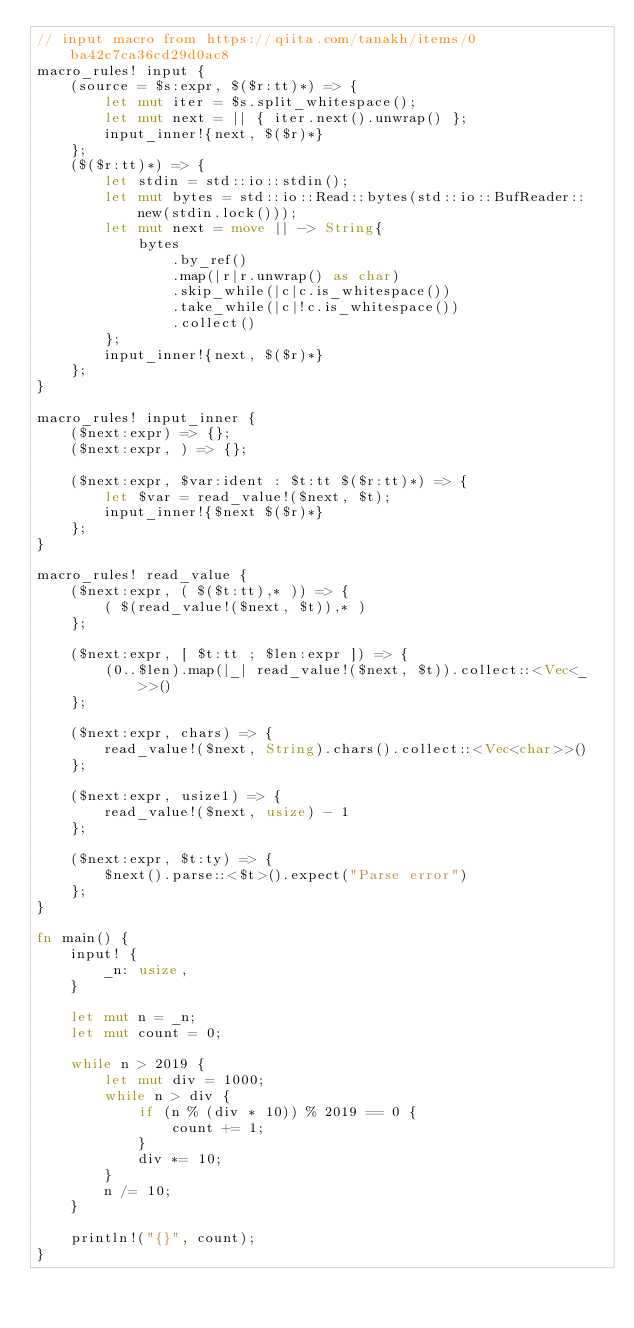Convert code to text. <code><loc_0><loc_0><loc_500><loc_500><_Rust_>// input macro from https://qiita.com/tanakh/items/0ba42c7ca36cd29d0ac8
macro_rules! input {
    (source = $s:expr, $($r:tt)*) => {
        let mut iter = $s.split_whitespace();
        let mut next = || { iter.next().unwrap() };
        input_inner!{next, $($r)*}
    };
    ($($r:tt)*) => {
        let stdin = std::io::stdin();
        let mut bytes = std::io::Read::bytes(std::io::BufReader::new(stdin.lock()));
        let mut next = move || -> String{
            bytes
                .by_ref()
                .map(|r|r.unwrap() as char)
                .skip_while(|c|c.is_whitespace())
                .take_while(|c|!c.is_whitespace())
                .collect()
        };
        input_inner!{next, $($r)*}
    };
}

macro_rules! input_inner {
    ($next:expr) => {};
    ($next:expr, ) => {};

    ($next:expr, $var:ident : $t:tt $($r:tt)*) => {
        let $var = read_value!($next, $t);
        input_inner!{$next $($r)*}
    };
}

macro_rules! read_value {
    ($next:expr, ( $($t:tt),* )) => {
        ( $(read_value!($next, $t)),* )
    };

    ($next:expr, [ $t:tt ; $len:expr ]) => {
        (0..$len).map(|_| read_value!($next, $t)).collect::<Vec<_>>()
    };

    ($next:expr, chars) => {
        read_value!($next, String).chars().collect::<Vec<char>>()
    };

    ($next:expr, usize1) => {
        read_value!($next, usize) - 1
    };

    ($next:expr, $t:ty) => {
        $next().parse::<$t>().expect("Parse error")
    };
}

fn main() {
    input! {
        _n: usize,
    }

    let mut n = _n;
    let mut count = 0;

    while n > 2019 {
        let mut div = 1000;
        while n > div {
            if (n % (div * 10)) % 2019 == 0 {
                count += 1;
            }
            div *= 10;
        }
        n /= 10;
    }

    println!("{}", count);
}
</code> 